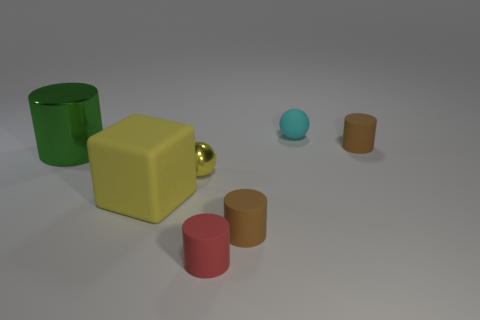Subtract all rubber cylinders. How many cylinders are left? 1 Subtract 1 blocks. How many blocks are left? 0 Add 1 big green things. How many objects exist? 8 Subtract all yellow balls. How many balls are left? 1 Subtract all cubes. How many objects are left? 6 Subtract all brown blocks. Subtract all blue cylinders. How many blocks are left? 1 Subtract all gray cubes. How many red cylinders are left? 1 Subtract all purple metal balls. Subtract all cyan matte things. How many objects are left? 6 Add 1 tiny yellow balls. How many tiny yellow balls are left? 2 Add 2 green objects. How many green objects exist? 3 